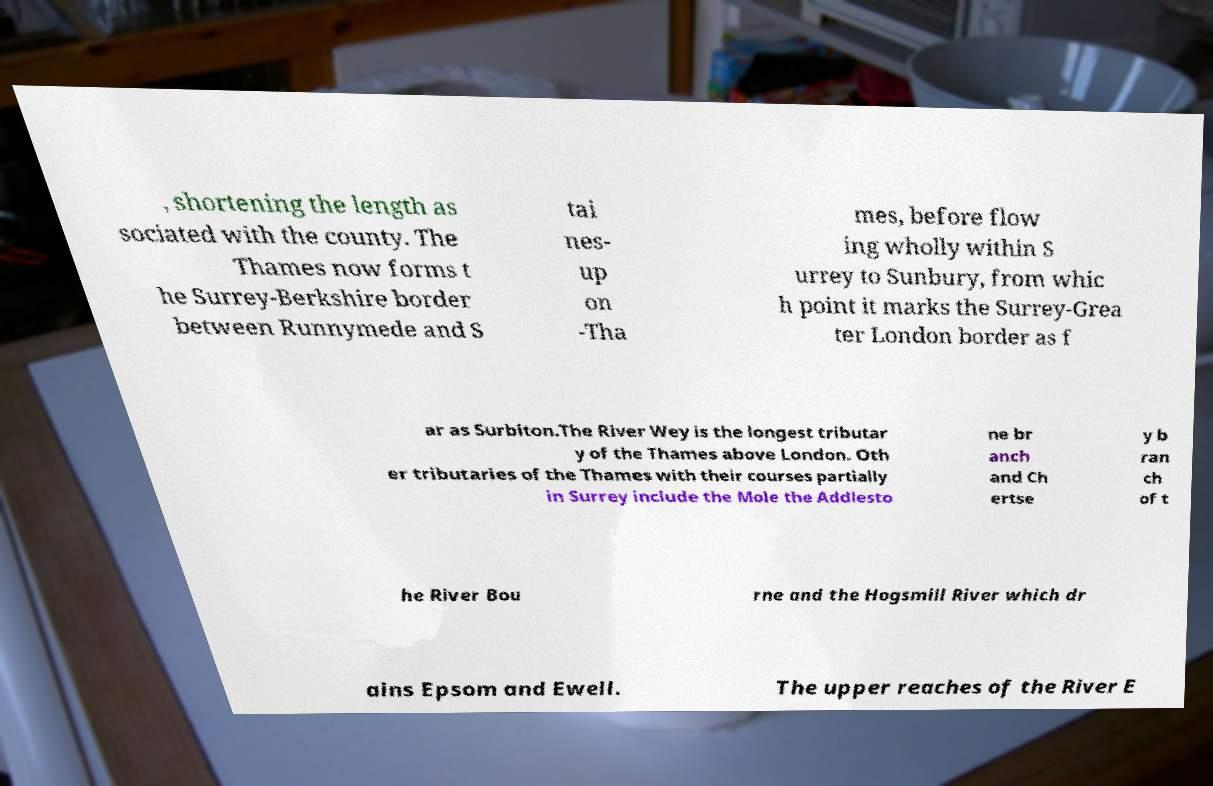There's text embedded in this image that I need extracted. Can you transcribe it verbatim? , shortening the length as sociated with the county. The Thames now forms t he Surrey-Berkshire border between Runnymede and S tai nes- up on -Tha mes, before flow ing wholly within S urrey to Sunbury, from whic h point it marks the Surrey-Grea ter London border as f ar as Surbiton.The River Wey is the longest tributar y of the Thames above London. Oth er tributaries of the Thames with their courses partially in Surrey include the Mole the Addlesto ne br anch and Ch ertse y b ran ch of t he River Bou rne and the Hogsmill River which dr ains Epsom and Ewell. The upper reaches of the River E 